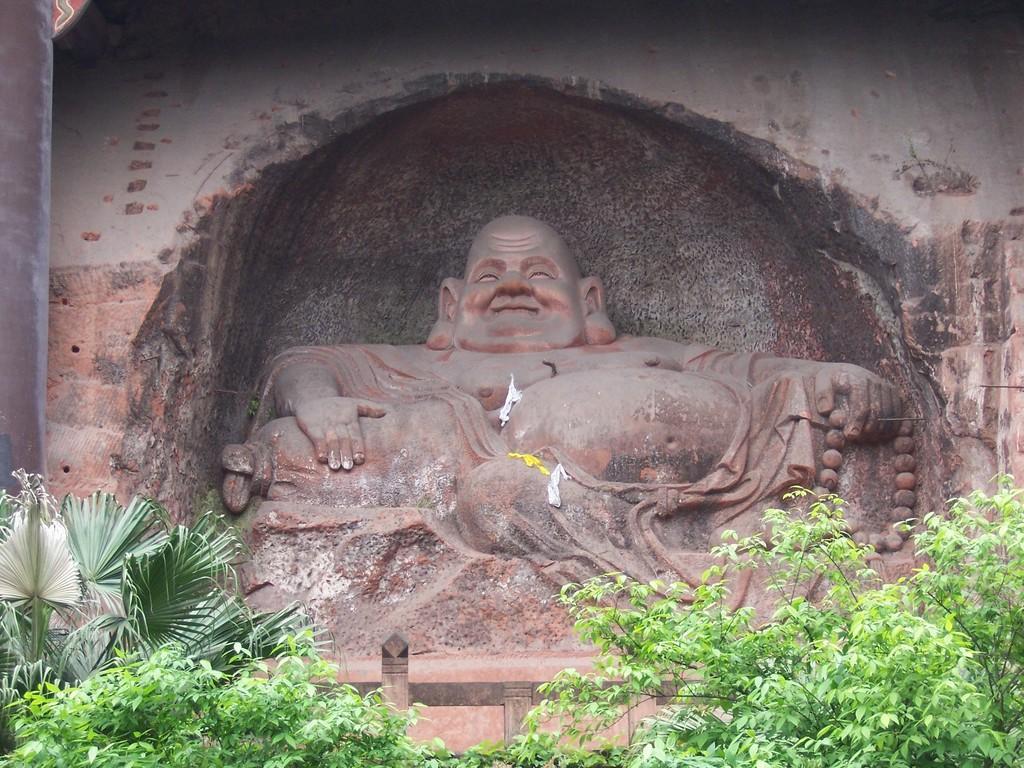How would you summarize this image in a sentence or two? It is the sculpture of laughing Buddha and there are many plants in front of the sculpture. 